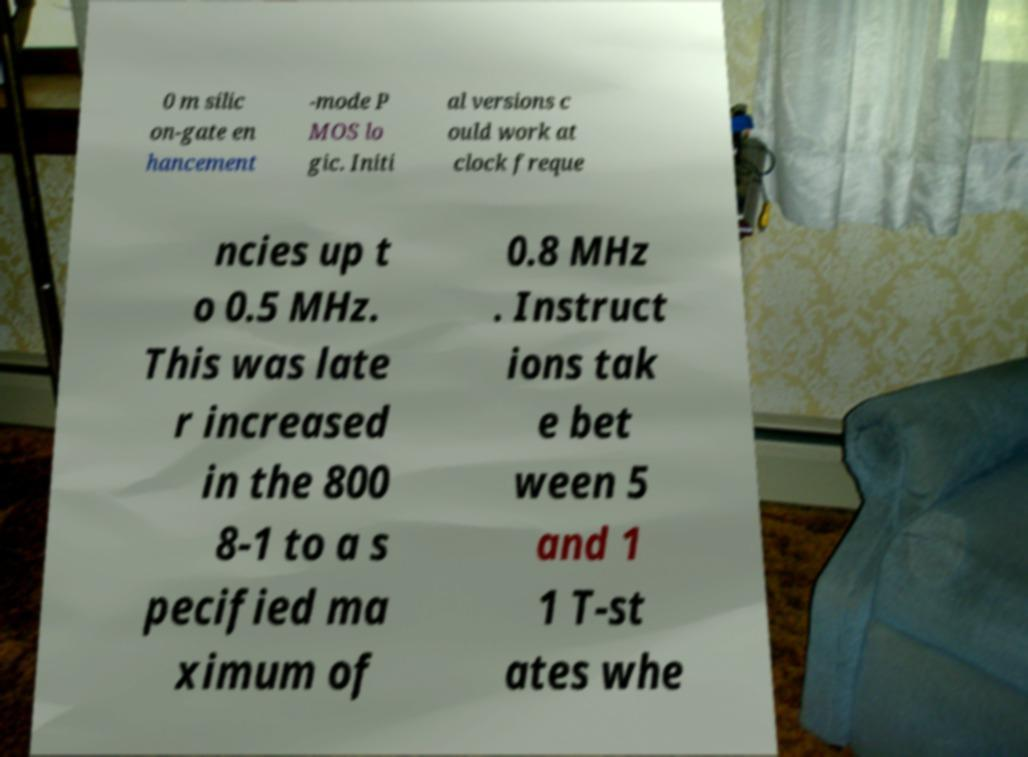There's text embedded in this image that I need extracted. Can you transcribe it verbatim? 0 m silic on-gate en hancement -mode P MOS lo gic. Initi al versions c ould work at clock freque ncies up t o 0.5 MHz. This was late r increased in the 800 8-1 to a s pecified ma ximum of 0.8 MHz . Instruct ions tak e bet ween 5 and 1 1 T-st ates whe 